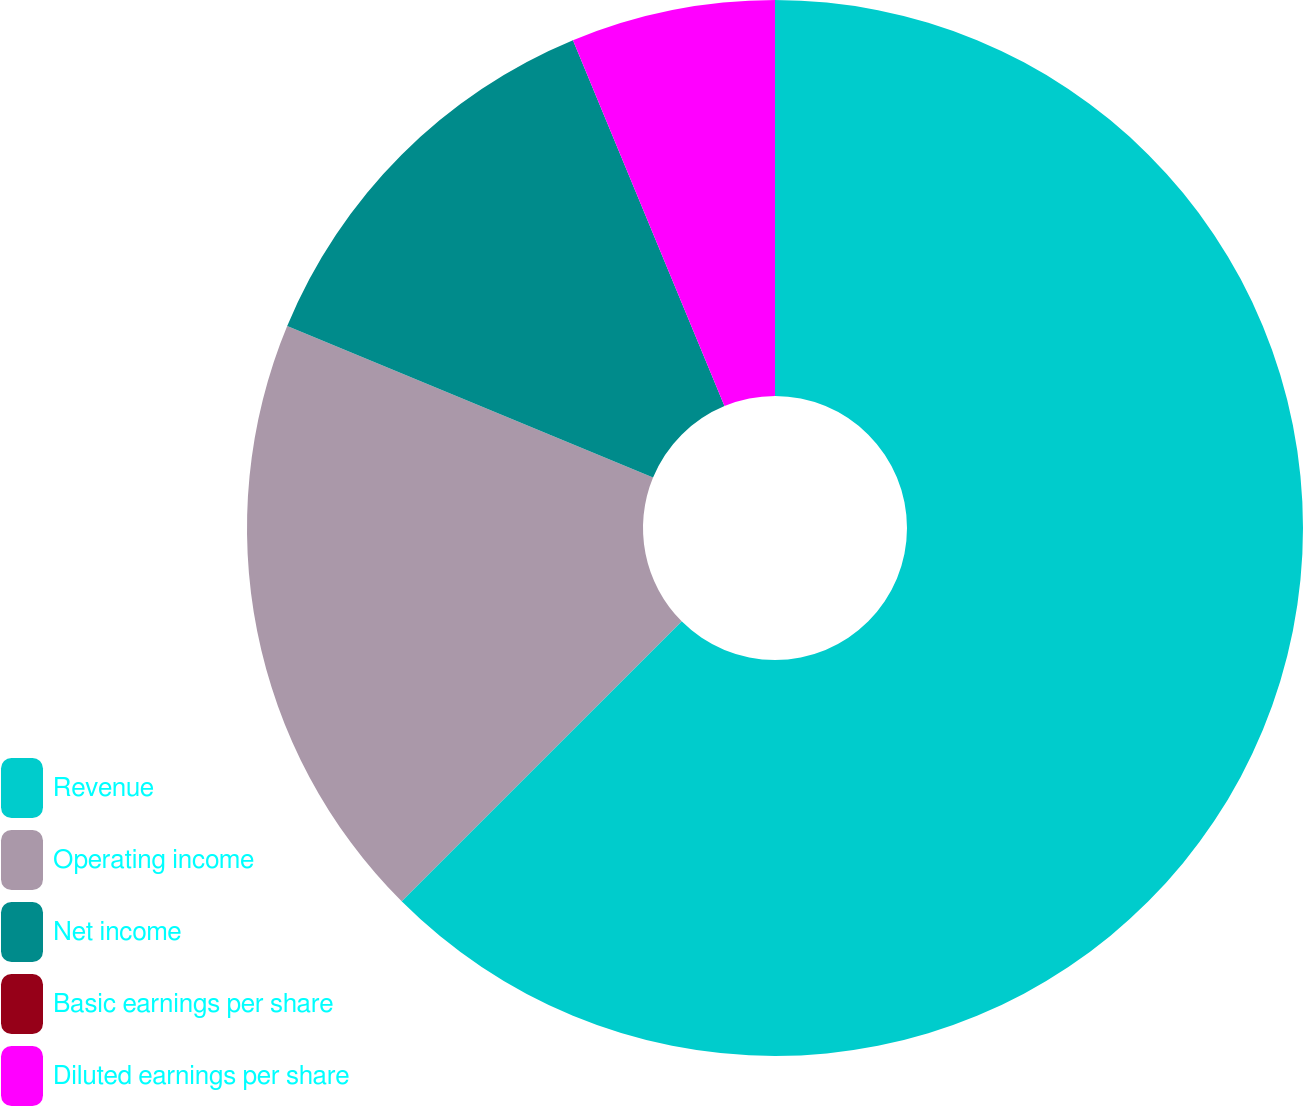Convert chart to OTSL. <chart><loc_0><loc_0><loc_500><loc_500><pie_chart><fcel>Revenue<fcel>Operating income<fcel>Net income<fcel>Basic earnings per share<fcel>Diluted earnings per share<nl><fcel>62.5%<fcel>18.75%<fcel>12.5%<fcel>0.0%<fcel>6.25%<nl></chart> 